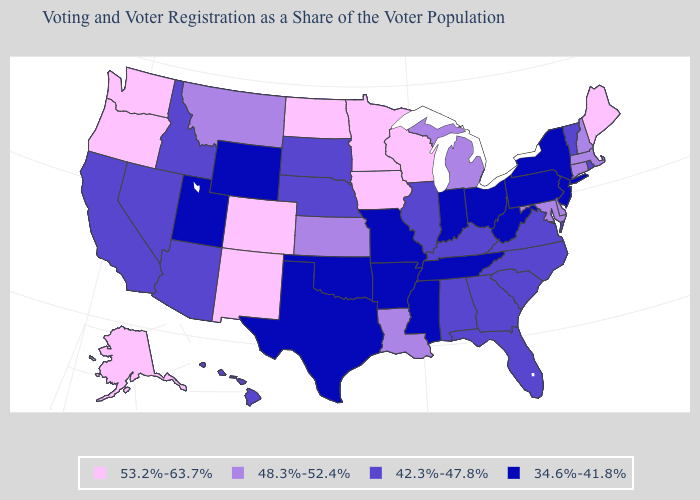What is the value of New York?
Keep it brief. 34.6%-41.8%. What is the value of Virginia?
Answer briefly. 42.3%-47.8%. Among the states that border Montana , does North Dakota have the highest value?
Concise answer only. Yes. Among the states that border Idaho , which have the lowest value?
Write a very short answer. Utah, Wyoming. Does Indiana have the lowest value in the MidWest?
Concise answer only. Yes. What is the value of North Carolina?
Keep it brief. 42.3%-47.8%. What is the highest value in states that border Montana?
Write a very short answer. 53.2%-63.7%. Which states hav the highest value in the MidWest?
Quick response, please. Iowa, Minnesota, North Dakota, Wisconsin. Name the states that have a value in the range 48.3%-52.4%?
Give a very brief answer. Connecticut, Delaware, Kansas, Louisiana, Maryland, Massachusetts, Michigan, Montana, New Hampshire. What is the lowest value in the Northeast?
Concise answer only. 34.6%-41.8%. Does Nebraska have a higher value than Florida?
Give a very brief answer. No. What is the lowest value in the USA?
Write a very short answer. 34.6%-41.8%. What is the highest value in states that border New Mexico?
Answer briefly. 53.2%-63.7%. Which states have the lowest value in the USA?
Answer briefly. Arkansas, Indiana, Mississippi, Missouri, New Jersey, New York, Ohio, Oklahoma, Pennsylvania, Tennessee, Texas, Utah, West Virginia, Wyoming. 